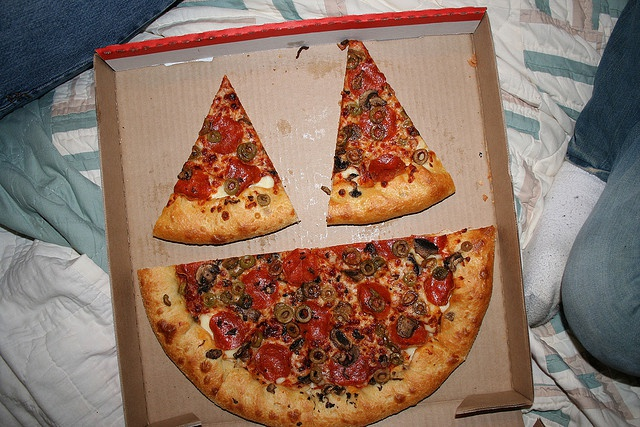Describe the objects in this image and their specific colors. I can see bed in black, darkgray, gray, and lightgray tones, pizza in black, maroon, and brown tones, people in black, gray, darkgray, and blue tones, pizza in black, brown, tan, and maroon tones, and pizza in black, maroon, brown, and tan tones in this image. 